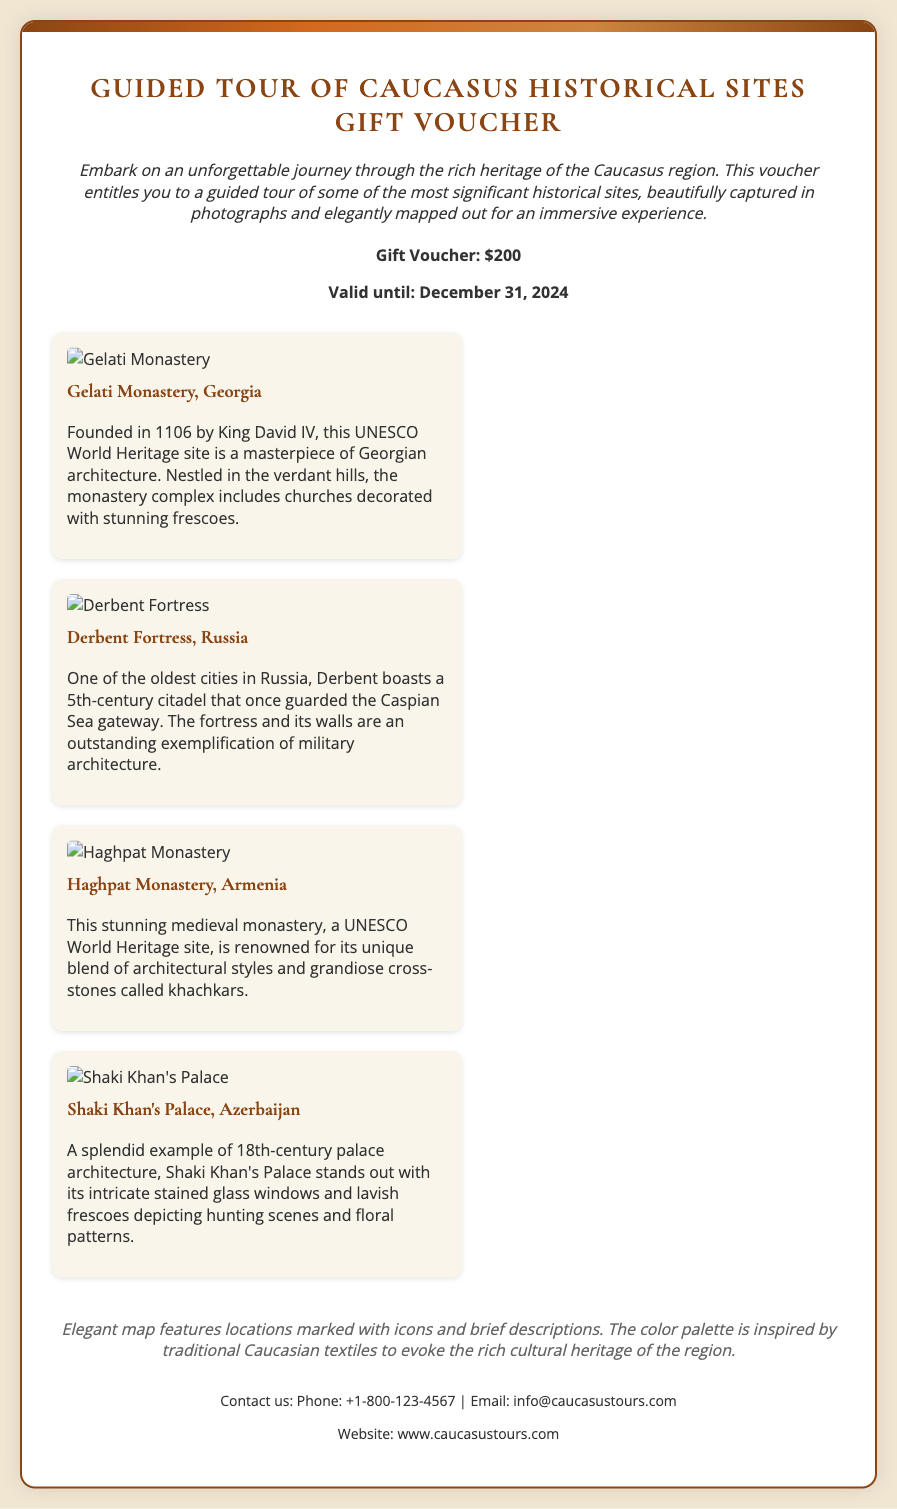What is the title of the voucher? The title of the voucher is a clear statement about the gift being offered.
Answer: Guided Tour of Caucasus Historical Sites Gift Voucher What is the value of the gift voucher? The value is explicitly stated as a monetary amount.
Answer: $200 Until when is the voucher valid? The validity date is specified in the document.
Answer: December 31, 2024 Which historical site is located in Georgia? The voucher lists several sites, and one is specifically mentioned as being in Georgia.
Answer: Gelati Monastery What architectural style is Haghpat Monastery known for? The document describes unique features of Haghpat Monastery, indicating its architectural uniqueness.
Answer: Blend of architectural styles How many highlights are featured on the voucher? The document itemizes the number of historical sites highlighted in the tour.
Answer: Four What is the main feature of the elegant map? The description provides insight into the function and aesthetics of the map included with the voucher.
Answer: Locations marked with icons What is the contact phone number for further inquiries? The document provides contact information prominently for potential customers.
Answer: +1-800-123-4567 